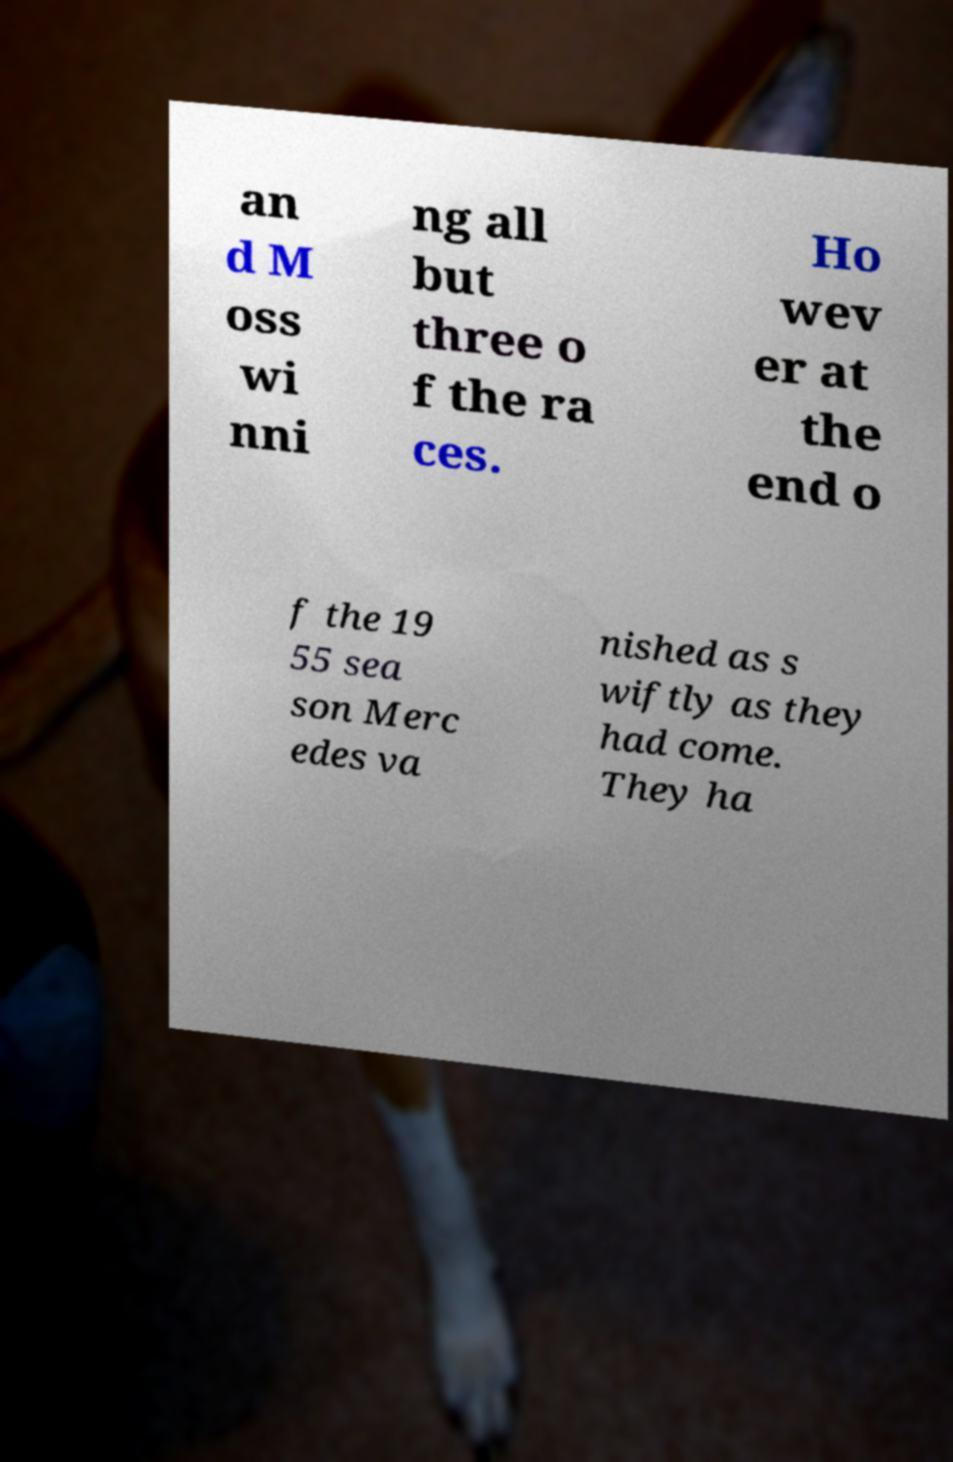Could you assist in decoding the text presented in this image and type it out clearly? an d M oss wi nni ng all but three o f the ra ces. Ho wev er at the end o f the 19 55 sea son Merc edes va nished as s wiftly as they had come. They ha 